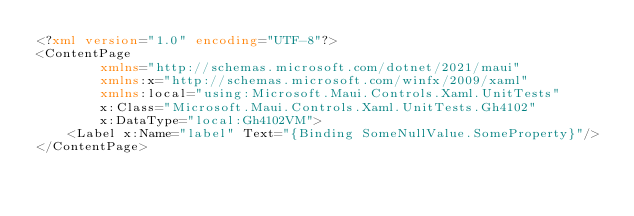Convert code to text. <code><loc_0><loc_0><loc_500><loc_500><_XML_><?xml version="1.0" encoding="UTF-8"?>
<ContentPage
		xmlns="http://schemas.microsoft.com/dotnet/2021/maui"
		xmlns:x="http://schemas.microsoft.com/winfx/2009/xaml"
		xmlns:local="using:Microsoft.Maui.Controls.Xaml.UnitTests"
		x:Class="Microsoft.Maui.Controls.Xaml.UnitTests.Gh4102"
		x:DataType="local:Gh4102VM">
	<Label x:Name="label" Text="{Binding SomeNullValue.SomeProperty}"/>
</ContentPage>
</code> 